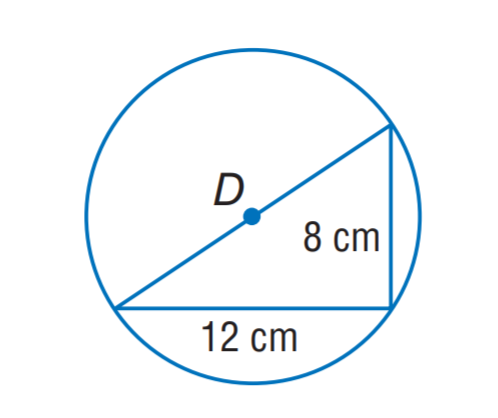Question: The triangle is inscribed in \odot D. Find the exact circumference of \odot D.
Choices:
A. 4 \sqrt { 13 } \pi
B. 4 \sqrt { 15 } \pi
C. 6 \sqrt { 13 } \pi
D. 6 \sqrt { 15 } \pi
Answer with the letter. Answer: A 